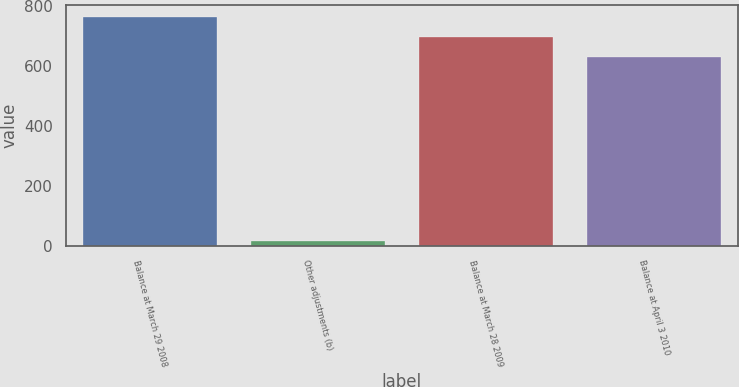Convert chart to OTSL. <chart><loc_0><loc_0><loc_500><loc_500><bar_chart><fcel>Balance at March 29 2008<fcel>Other adjustments (b)<fcel>Balance at March 28 2009<fcel>Balance at April 3 2010<nl><fcel>762.16<fcel>15.5<fcel>695.23<fcel>628.3<nl></chart> 